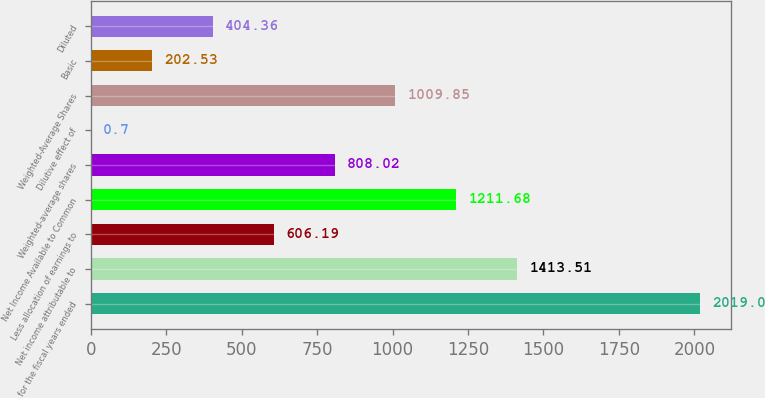<chart> <loc_0><loc_0><loc_500><loc_500><bar_chart><fcel>for the fiscal years ended<fcel>Net income attributable to<fcel>Less allocation of earnings to<fcel>Net Income Available to Common<fcel>Weighted-average shares<fcel>Dilutive effect of<fcel>Weighted-Average Shares<fcel>Basic<fcel>Diluted<nl><fcel>2019<fcel>1413.51<fcel>606.19<fcel>1211.68<fcel>808.02<fcel>0.7<fcel>1009.85<fcel>202.53<fcel>404.36<nl></chart> 